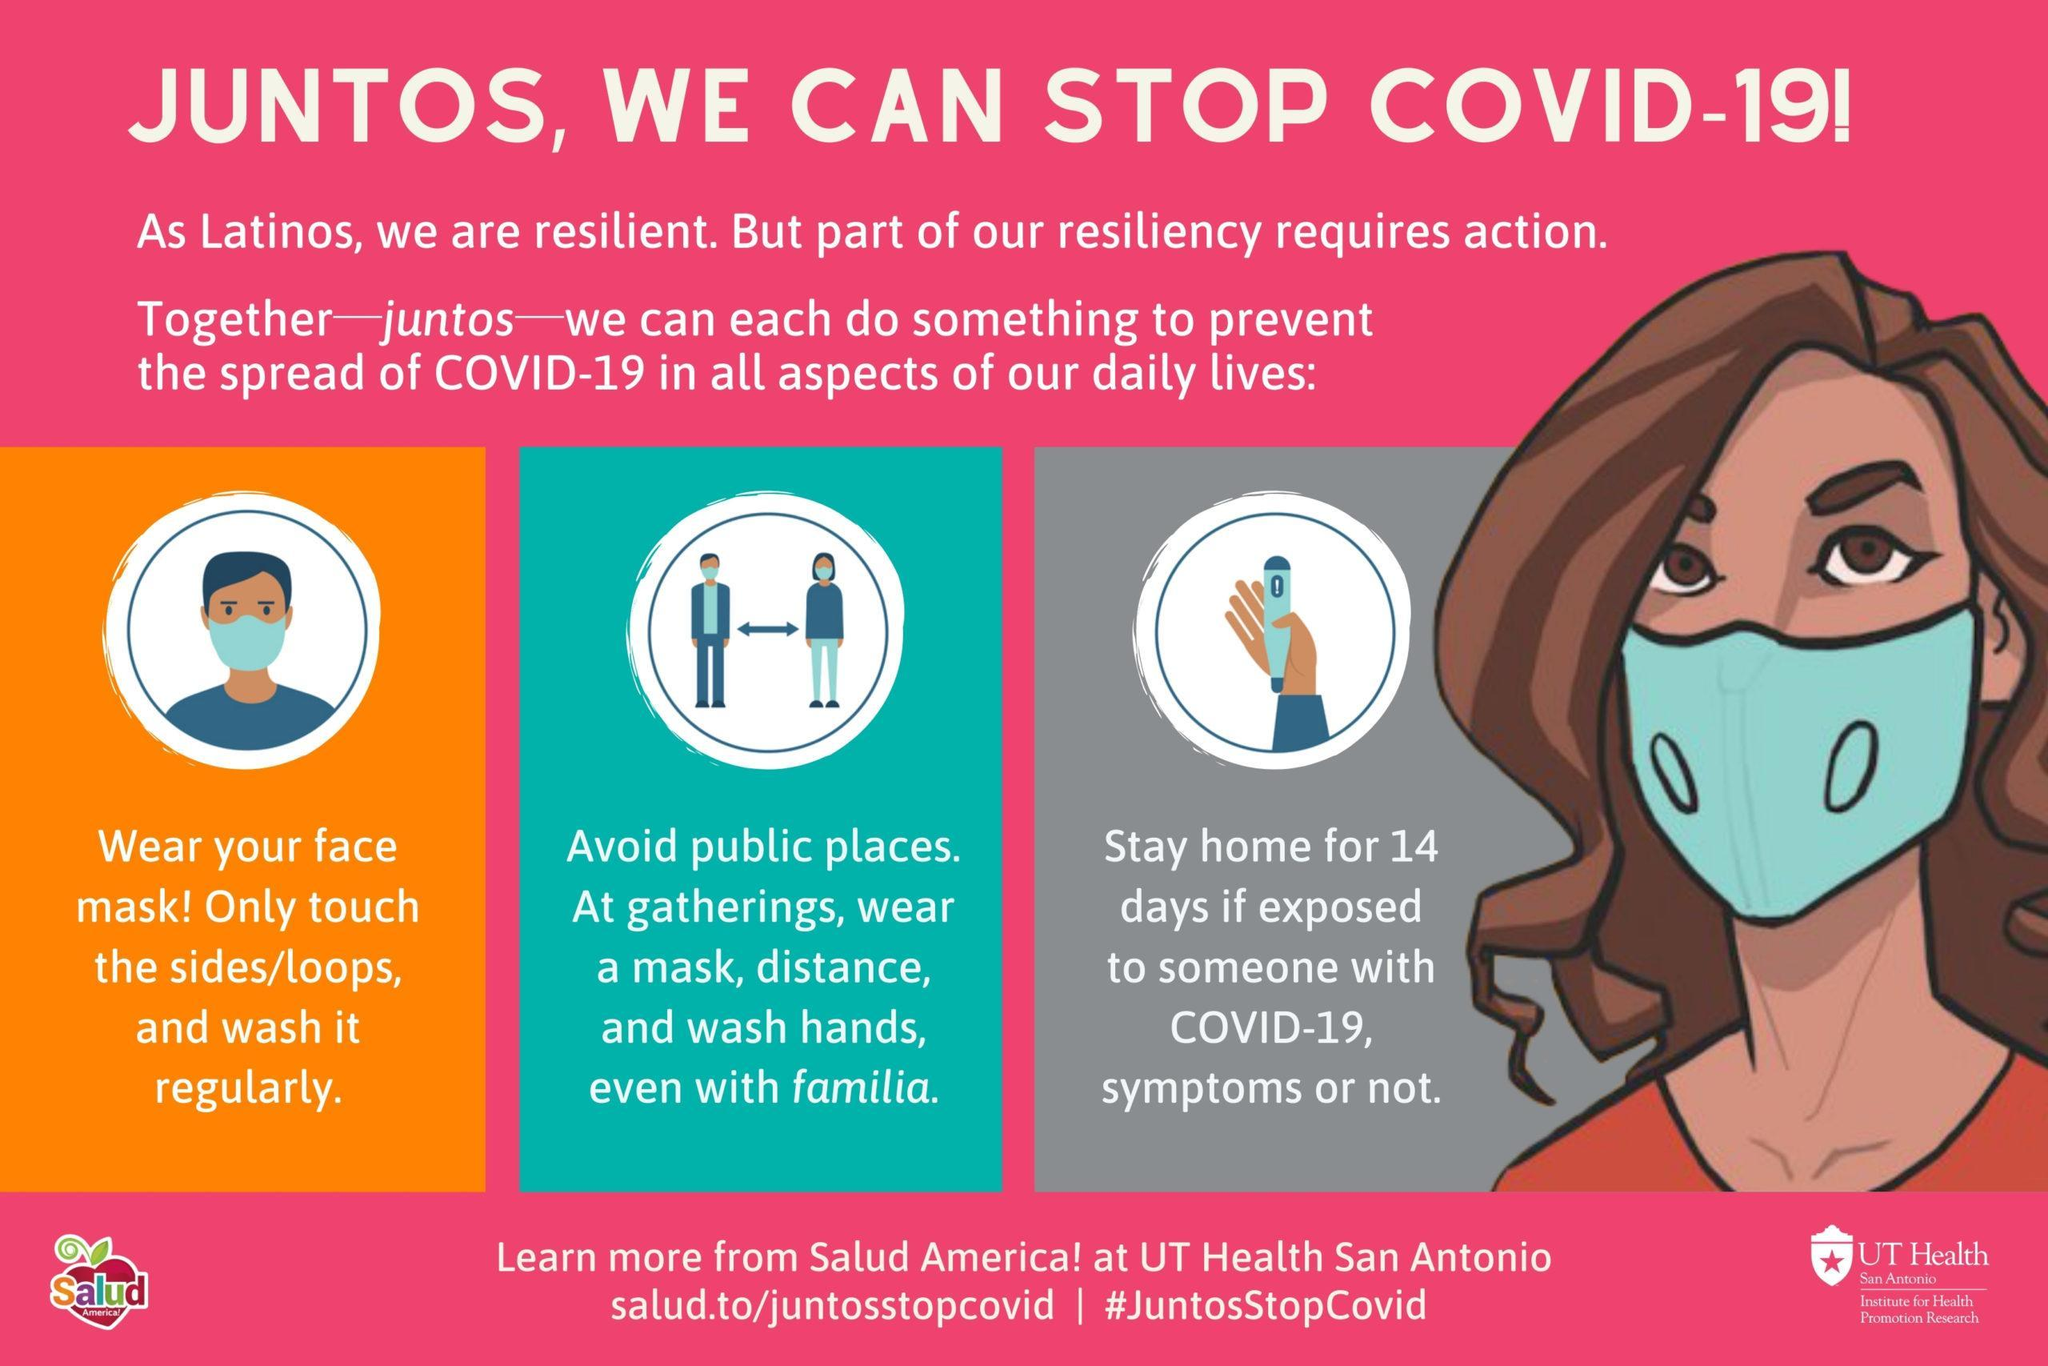What are the 3 precautions to be taken at gatherings (including family gatherings)?
Answer the question with a short phrase. Wear a mask, distance, wash hands What is the colour of the face mask worn by the lady - red, blue, yellow or brown? Blue What is the meaning of Juntos in English? Together Who are the resilient people? Latinos Which part of a face mask should only be touched? Sides/loops How often should we wash the face mask? Regularly What should be done if one is exposed to someone with covid-19? Stay home for 14 days 